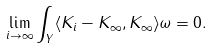<formula> <loc_0><loc_0><loc_500><loc_500>\lim _ { i \rightarrow \infty } \int _ { Y } \langle K _ { i } - K _ { \infty } , K _ { \infty } \rangle \omega = 0 .</formula> 